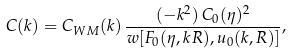Convert formula to latex. <formula><loc_0><loc_0><loc_500><loc_500>C ( k ) = C _ { W M } ( k ) \, \frac { ( - k ^ { 2 } ) \, C _ { 0 } ( \eta ) ^ { 2 } } { w [ F _ { 0 } ( \eta , k R ) , u _ { 0 } ( k , R ) ] } ,</formula> 